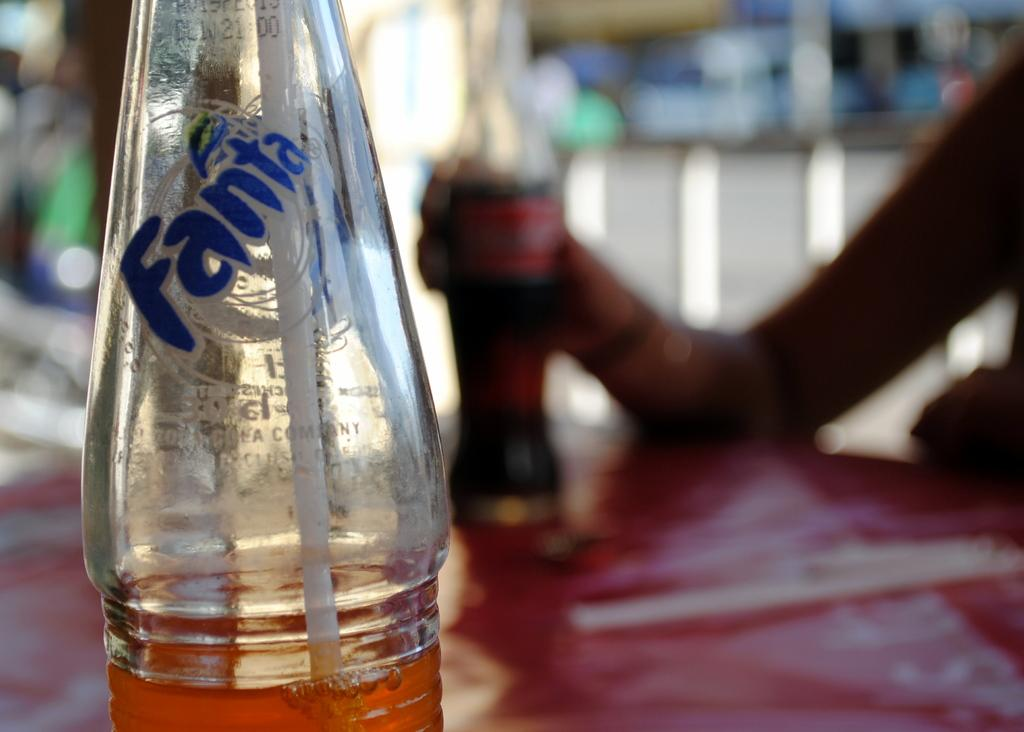What type of drink is in the bottle that is visible in the image? There is a Fanta bottle in the image. How is the person consuming the drink in the Fanta bottle? There is a straw in the Fanta bottle. What is the person doing in the image? A person is sitting in the image. What other type of drink is the person holding? The person is holding a Coke bottle. What type of property does the person own in the image? There is no information about property ownership in the image. What health concerns might the person have in the image? There is no information about the person's health in the image. 